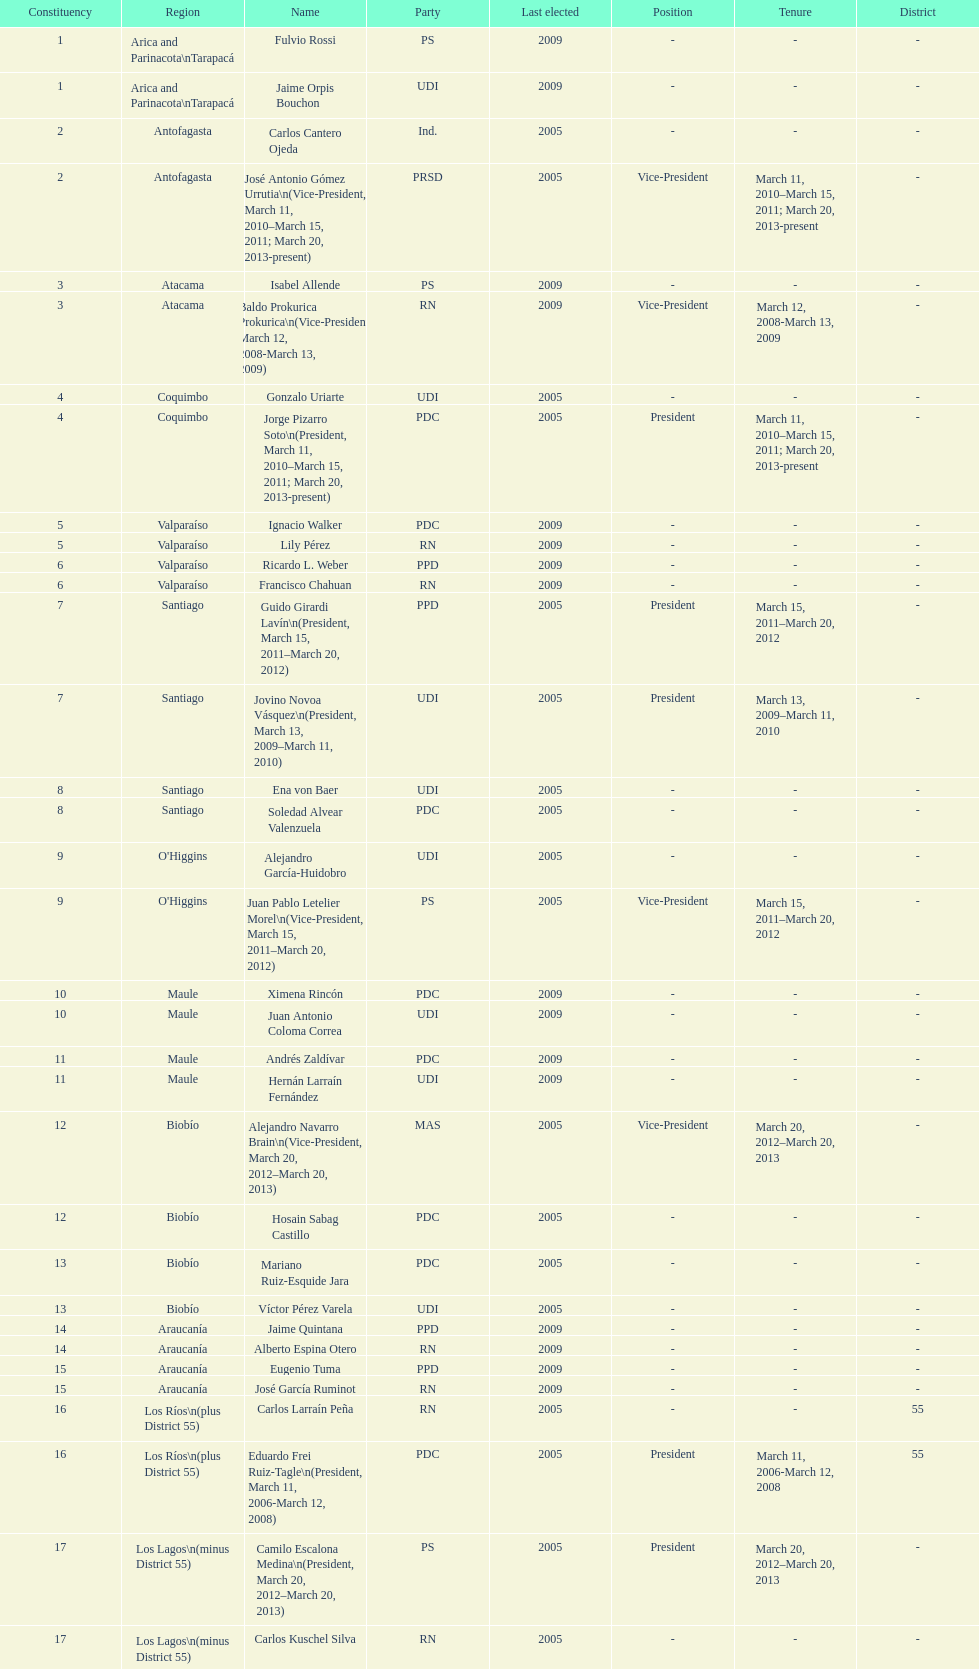Who was not last elected in either 2005 or 2009? Antonio Horvath Kiss. 